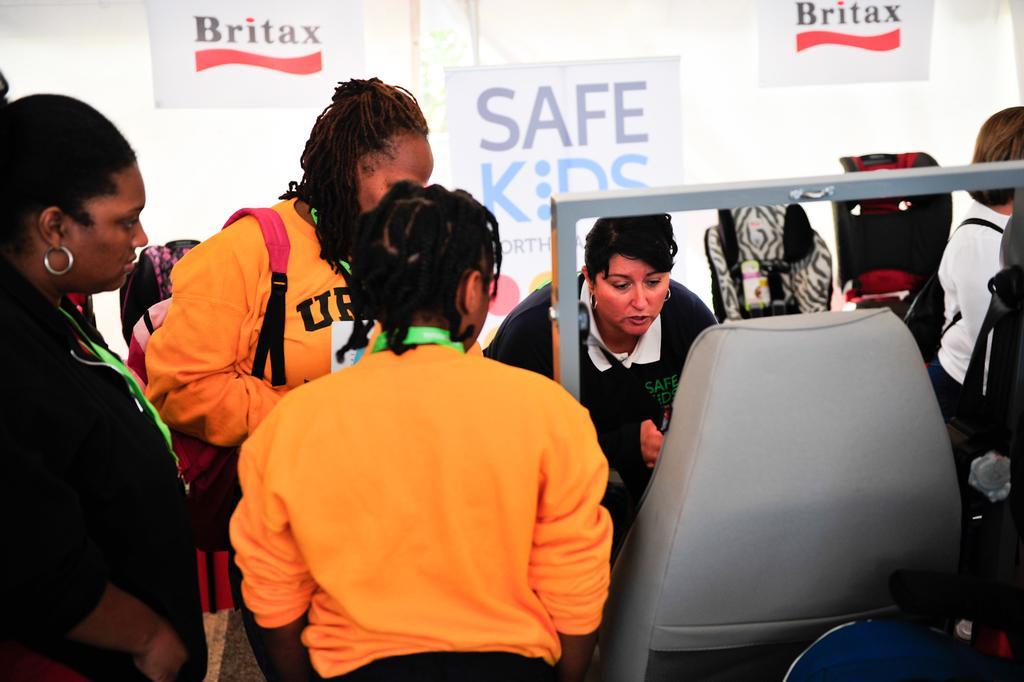Please provide a concise description of this image. As we can see in the image there is a chair, few people here and there and in the background there are banners. 